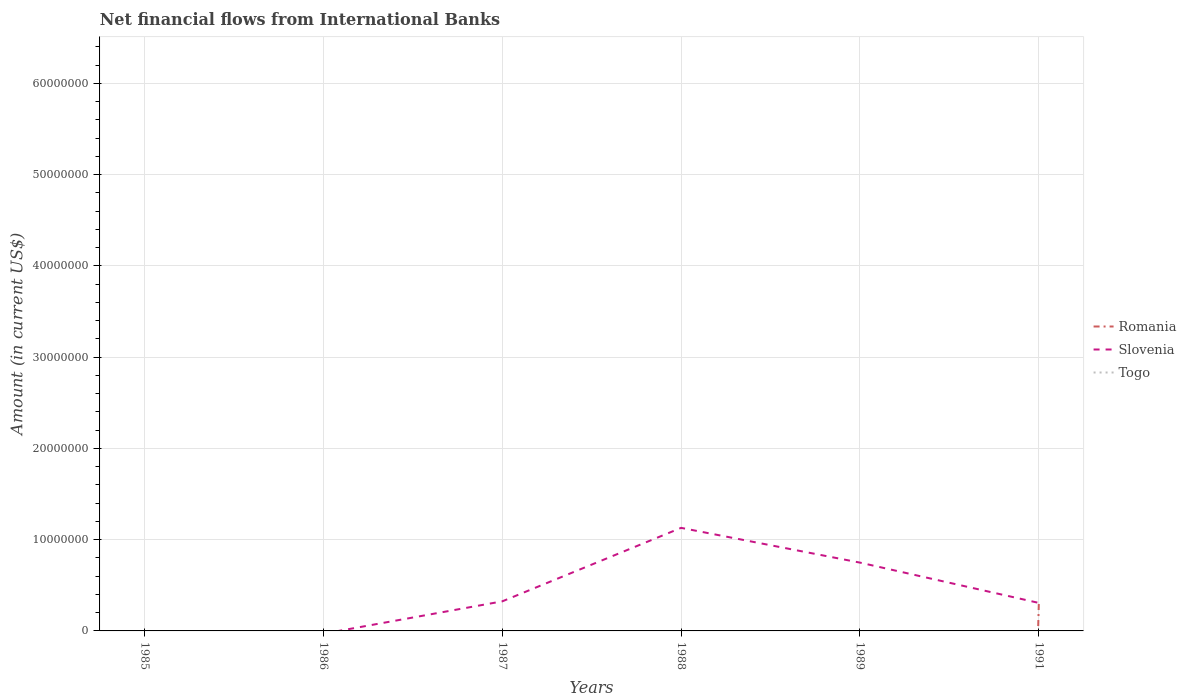Does the line corresponding to Romania intersect with the line corresponding to Slovenia?
Provide a succinct answer. Yes. Is the number of lines equal to the number of legend labels?
Give a very brief answer. No. Across all years, what is the maximum net financial aid flows in Slovenia?
Your answer should be compact. 0. What is the total net financial aid flows in Slovenia in the graph?
Offer a terse response. -8.05e+06. What is the difference between the highest and the second highest net financial aid flows in Romania?
Give a very brief answer. 3.16e+06. Is the net financial aid flows in Slovenia strictly greater than the net financial aid flows in Romania over the years?
Offer a terse response. No. How many lines are there?
Make the answer very short. 2. What is the difference between two consecutive major ticks on the Y-axis?
Provide a short and direct response. 1.00e+07. Are the values on the major ticks of Y-axis written in scientific E-notation?
Your answer should be compact. No. How many legend labels are there?
Ensure brevity in your answer.  3. How are the legend labels stacked?
Your answer should be compact. Vertical. What is the title of the graph?
Your answer should be very brief. Net financial flows from International Banks. Does "Cabo Verde" appear as one of the legend labels in the graph?
Keep it short and to the point. No. What is the label or title of the X-axis?
Your answer should be compact. Years. What is the Amount (in current US$) of Romania in 1985?
Offer a very short reply. 0. What is the Amount (in current US$) of Slovenia in 1985?
Your response must be concise. 0. What is the Amount (in current US$) of Togo in 1985?
Your answer should be very brief. 0. What is the Amount (in current US$) in Romania in 1987?
Offer a very short reply. 0. What is the Amount (in current US$) of Slovenia in 1987?
Give a very brief answer. 3.24e+06. What is the Amount (in current US$) of Slovenia in 1988?
Your answer should be compact. 1.13e+07. What is the Amount (in current US$) in Togo in 1988?
Give a very brief answer. 0. What is the Amount (in current US$) in Slovenia in 1989?
Provide a short and direct response. 7.49e+06. What is the Amount (in current US$) of Togo in 1989?
Give a very brief answer. 0. What is the Amount (in current US$) of Romania in 1991?
Give a very brief answer. 3.16e+06. What is the Amount (in current US$) of Slovenia in 1991?
Your answer should be very brief. 3.07e+06. What is the Amount (in current US$) of Togo in 1991?
Provide a succinct answer. 0. Across all years, what is the maximum Amount (in current US$) of Romania?
Ensure brevity in your answer.  3.16e+06. Across all years, what is the maximum Amount (in current US$) in Slovenia?
Offer a very short reply. 1.13e+07. Across all years, what is the minimum Amount (in current US$) in Romania?
Your response must be concise. 0. What is the total Amount (in current US$) in Romania in the graph?
Keep it short and to the point. 3.16e+06. What is the total Amount (in current US$) of Slovenia in the graph?
Make the answer very short. 2.51e+07. What is the difference between the Amount (in current US$) of Slovenia in 1987 and that in 1988?
Ensure brevity in your answer.  -8.05e+06. What is the difference between the Amount (in current US$) of Slovenia in 1987 and that in 1989?
Provide a succinct answer. -4.25e+06. What is the difference between the Amount (in current US$) in Slovenia in 1987 and that in 1991?
Provide a short and direct response. 1.72e+05. What is the difference between the Amount (in current US$) of Slovenia in 1988 and that in 1989?
Give a very brief answer. 3.81e+06. What is the difference between the Amount (in current US$) of Slovenia in 1988 and that in 1991?
Your answer should be compact. 8.23e+06. What is the difference between the Amount (in current US$) of Slovenia in 1989 and that in 1991?
Your answer should be very brief. 4.42e+06. What is the average Amount (in current US$) of Romania per year?
Your response must be concise. 5.27e+05. What is the average Amount (in current US$) in Slovenia per year?
Provide a succinct answer. 4.18e+06. In the year 1991, what is the difference between the Amount (in current US$) of Romania and Amount (in current US$) of Slovenia?
Make the answer very short. 9.17e+04. What is the ratio of the Amount (in current US$) in Slovenia in 1987 to that in 1988?
Your response must be concise. 0.29. What is the ratio of the Amount (in current US$) in Slovenia in 1987 to that in 1989?
Make the answer very short. 0.43. What is the ratio of the Amount (in current US$) in Slovenia in 1987 to that in 1991?
Give a very brief answer. 1.06. What is the ratio of the Amount (in current US$) in Slovenia in 1988 to that in 1989?
Offer a terse response. 1.51. What is the ratio of the Amount (in current US$) in Slovenia in 1988 to that in 1991?
Make the answer very short. 3.68. What is the ratio of the Amount (in current US$) of Slovenia in 1989 to that in 1991?
Give a very brief answer. 2.44. What is the difference between the highest and the second highest Amount (in current US$) of Slovenia?
Your response must be concise. 3.81e+06. What is the difference between the highest and the lowest Amount (in current US$) of Romania?
Your answer should be compact. 3.16e+06. What is the difference between the highest and the lowest Amount (in current US$) of Slovenia?
Give a very brief answer. 1.13e+07. 